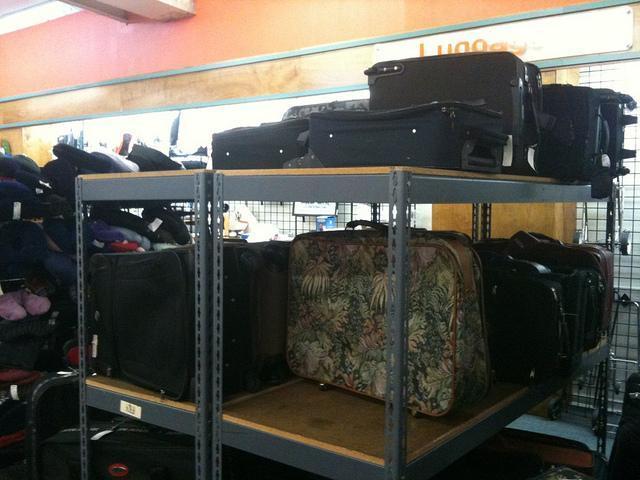How many suitcases are in the picture?
Give a very brief answer. 10. 